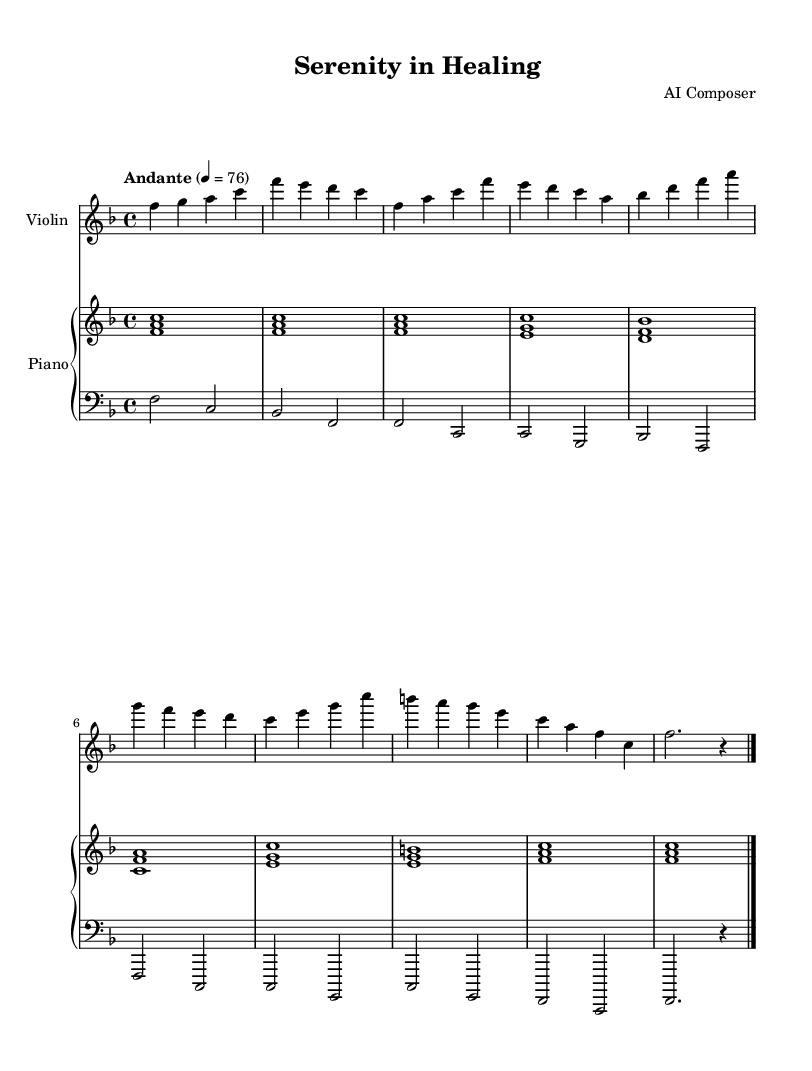What is the key signature of this music? The key signature is F major, which has one flat (B flat). This can be determined by looking at the key signature area at the beginning of the music, where one flat is indicated.
Answer: F major What is the time signature of this music? The time signature is 4/4. This is indicated at the beginning of the score, showing there are four beats in each measure and the quarter note gets one beat.
Answer: 4/4 What is the tempo marking in this music? The tempo marking is Andante, which typically means a moderate pace. It is indicated above the staff and describes how the piece should be performed.
Answer: Andante How many sections are present in this piece? The piece consists of three main sections: Intro, Section A, and Section B, plus a Coda. This can be identified from the structure laid out in the music, with clear divisions marked.
Answer: Four What instruments are featured in this composition? The composition features a violin and a piano, which can be seen in the header that specifies "Violin" and "Piano" as the instruments for the respective staves.
Answer: Violin and Piano What is the final chord in the Coda? The final chord in the Coda is F major, which can be identified by looking at the last measure where the F note is played along with A and C notes, confirming the chord.
Answer: F major Which section is the first to introduce a melody? The first section to introduce a melody is Section A. This can be discerned from the notation patterns, where the melodic line is prominent compared to the accompaniment in the earlier sections.
Answer: Section A 